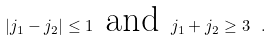Convert formula to latex. <formula><loc_0><loc_0><loc_500><loc_500>| j _ { 1 } - j _ { 2 } | \leq 1 \text { and } j _ { 1 } + j _ { 2 } \geq 3 \ .</formula> 